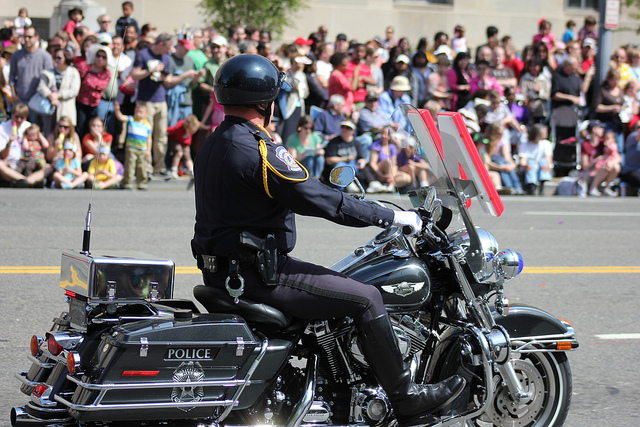<image>What city does the motorcycle cop work in? It's not clear what city the motorcycle cop works in. It could be Chicago, New York, Los Angeles, or Dallas. What city does the motorcycle cop work in? I am not sure what city does the motorcycle cop work in. It can be Chicago, New York, Los Angeles, Dallas, or any other city in the United States. 